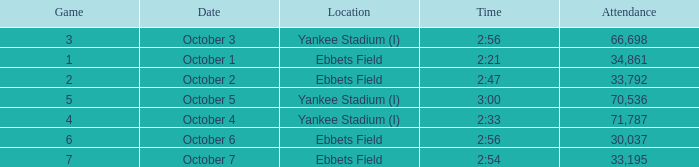Location of ebbets field, and a Time of 2:56, and a Game larger than 6 has what sum of attendance? None. 